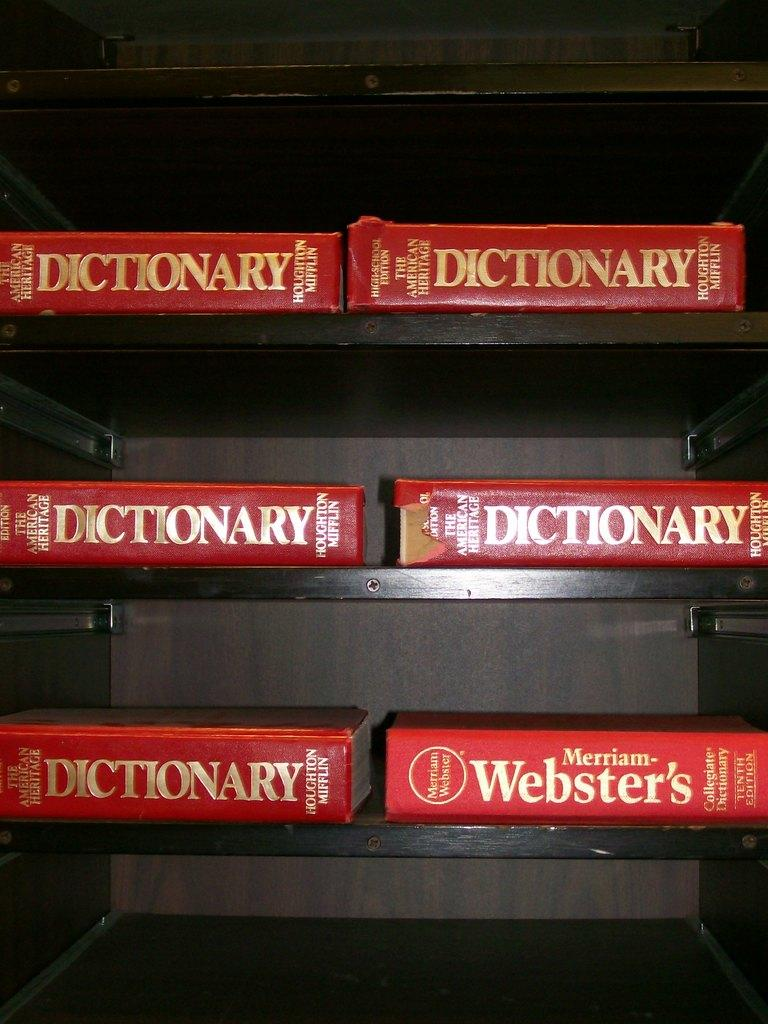Provide a one-sentence caption for the provided image. Six red Webster's dictionaries in gold lettering on black shelves. 